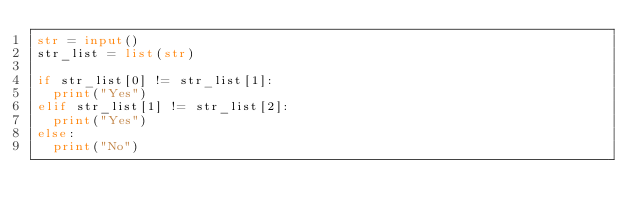<code> <loc_0><loc_0><loc_500><loc_500><_Python_>str = input()
str_list = list(str)
 
if str_list[0] != str_list[1]:
  print("Yes")
elif str_list[1] != str_list[2]:
  print("Yes")
else:
  print("No")</code> 